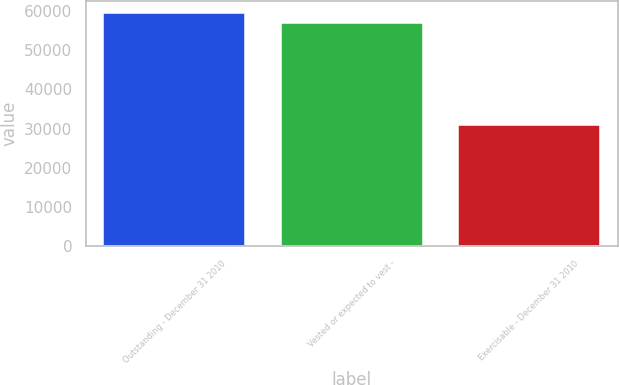Convert chart. <chart><loc_0><loc_0><loc_500><loc_500><bar_chart><fcel>Outstanding - December 31 2010<fcel>Vested or expected to vest -<fcel>Exercisable - December 31 2010<nl><fcel>59607.5<fcel>56992<fcel>30946<nl></chart> 